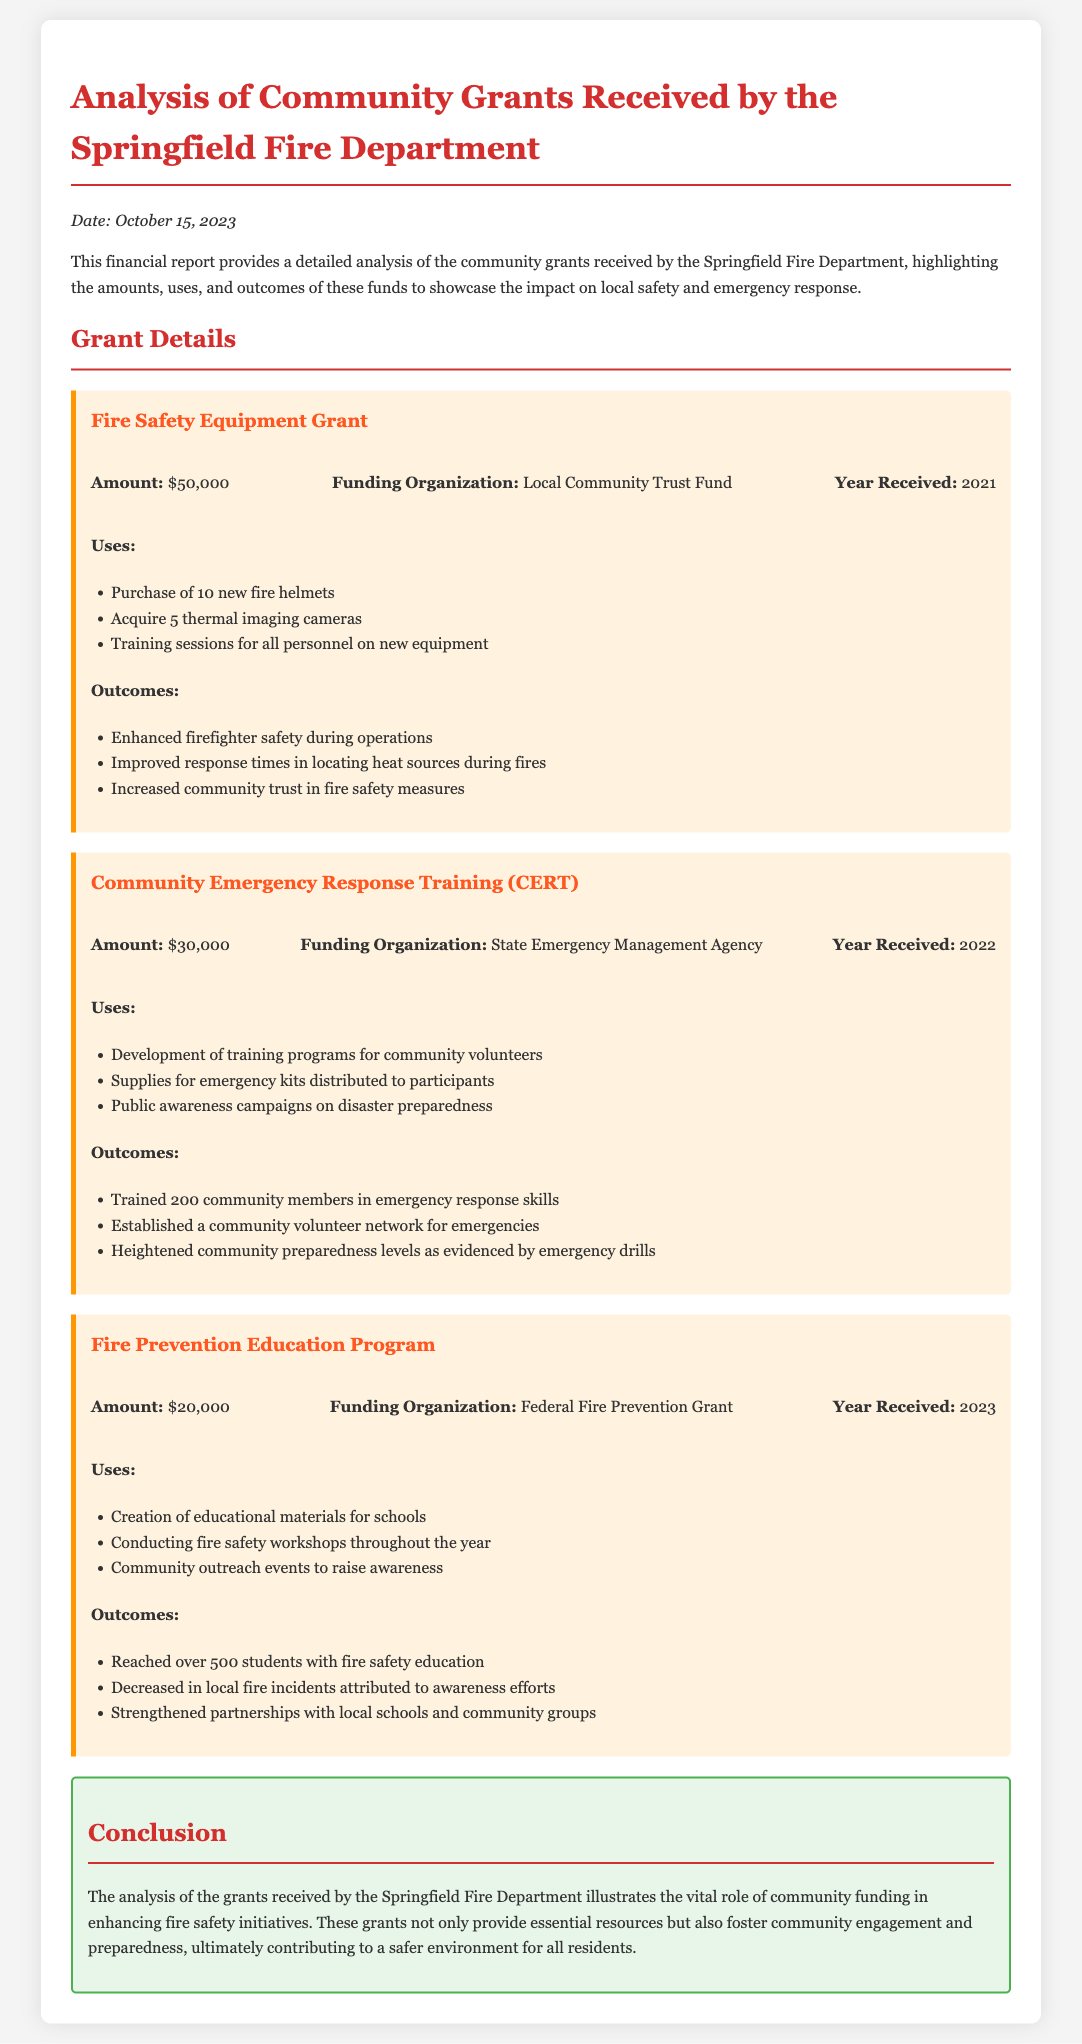What is the total amount of grants received by the Springfield Fire Department? The total amount is the sum of all individual grants: $50,000 + $30,000 + $20,000 = $100,000.
Answer: $100,000 What year was the Fire Safety Equipment Grant received? The Fire Safety Equipment Grant was received in 2021.
Answer: 2021 Who funded the Community Emergency Response Training? The Community Emergency Response Training was funded by the State Emergency Management Agency.
Answer: State Emergency Management Agency What was one key outcome of the Fire Prevention Education Program? One key outcome was a decrease in local fire incidents attributed to awareness efforts.
Answer: Decrease in local fire incidents How many community members were trained through the CERT program? The document states that 200 community members were trained in emergency response skills.
Answer: 200 What type of equipment was purchased with the Fire Safety Equipment Grant? The grant was used to purchase 10 new fire helmets and 5 thermal imaging cameras.
Answer: 10 new fire helmets and 5 thermal imaging cameras What was a use of the funding from the Fire Prevention Education Program? A use of the funding was creating educational materials for schools.
Answer: Creation of educational materials for schools In which year was the Fire Prevention Education Program grant received? The Fire Prevention Education Program grant was received in 2023.
Answer: 2023 What was the total allocation for the Community Emergency Response Training project? The total allocation for this project was $30,000.
Answer: $30,000 